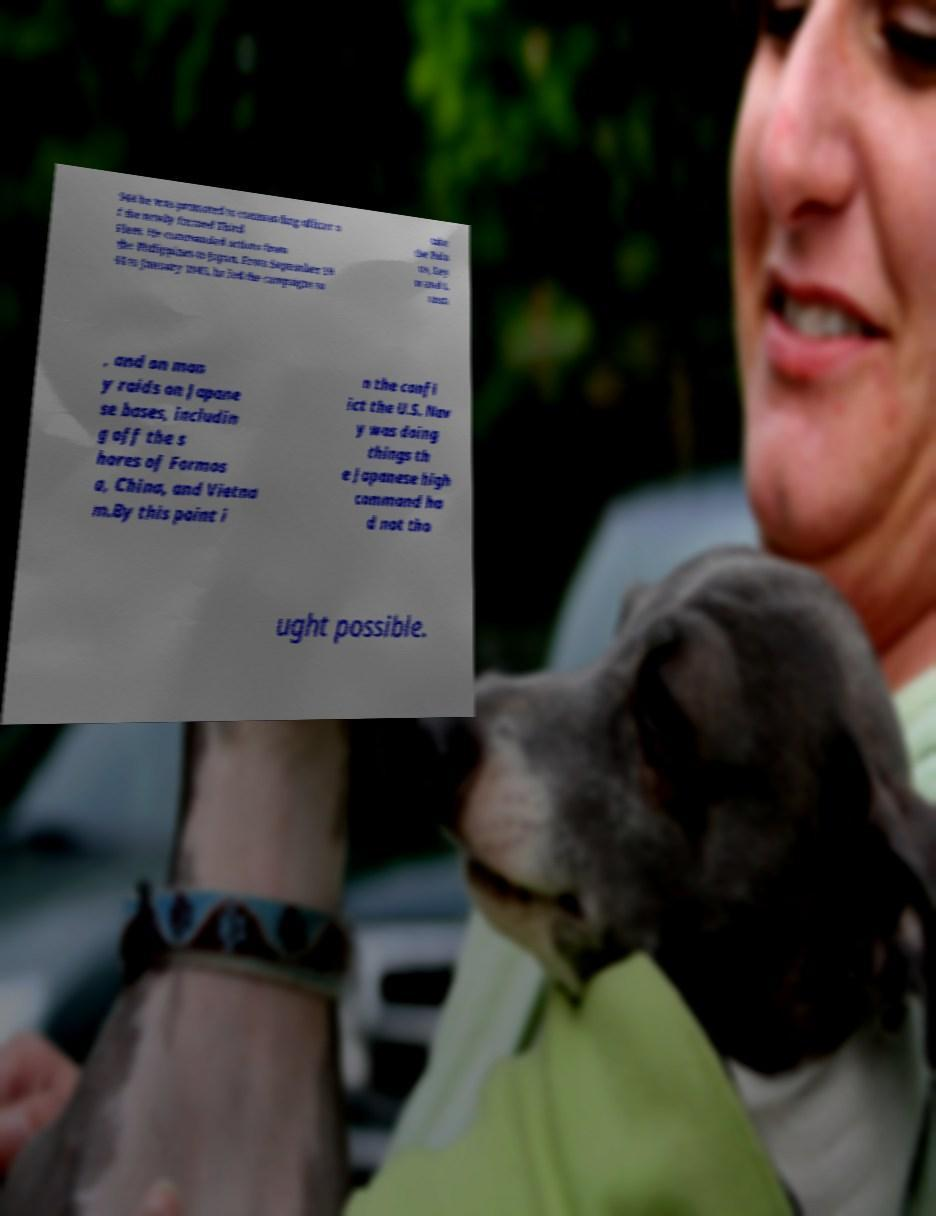Could you assist in decoding the text presented in this image and type it out clearly? 944 he was promoted to commanding officer o f the newly formed Third Fleet. He commanded actions from the Philippines to Japan. From September 19 44 to January 1945, he led the campaigns to take the Pala us, Ley te and L uzon , and on man y raids on Japane se bases, includin g off the s hores of Formos a, China, and Vietna m.By this point i n the confl ict the U.S. Nav y was doing things th e Japanese high command ha d not tho ught possible. 